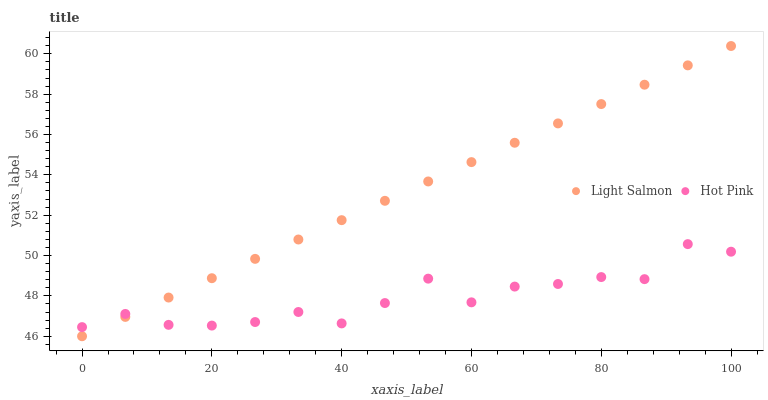Does Hot Pink have the minimum area under the curve?
Answer yes or no. Yes. Does Light Salmon have the maximum area under the curve?
Answer yes or no. Yes. Does Hot Pink have the maximum area under the curve?
Answer yes or no. No. Is Light Salmon the smoothest?
Answer yes or no. Yes. Is Hot Pink the roughest?
Answer yes or no. Yes. Is Hot Pink the smoothest?
Answer yes or no. No. Does Light Salmon have the lowest value?
Answer yes or no. Yes. Does Hot Pink have the lowest value?
Answer yes or no. No. Does Light Salmon have the highest value?
Answer yes or no. Yes. Does Hot Pink have the highest value?
Answer yes or no. No. Does Light Salmon intersect Hot Pink?
Answer yes or no. Yes. Is Light Salmon less than Hot Pink?
Answer yes or no. No. Is Light Salmon greater than Hot Pink?
Answer yes or no. No. 